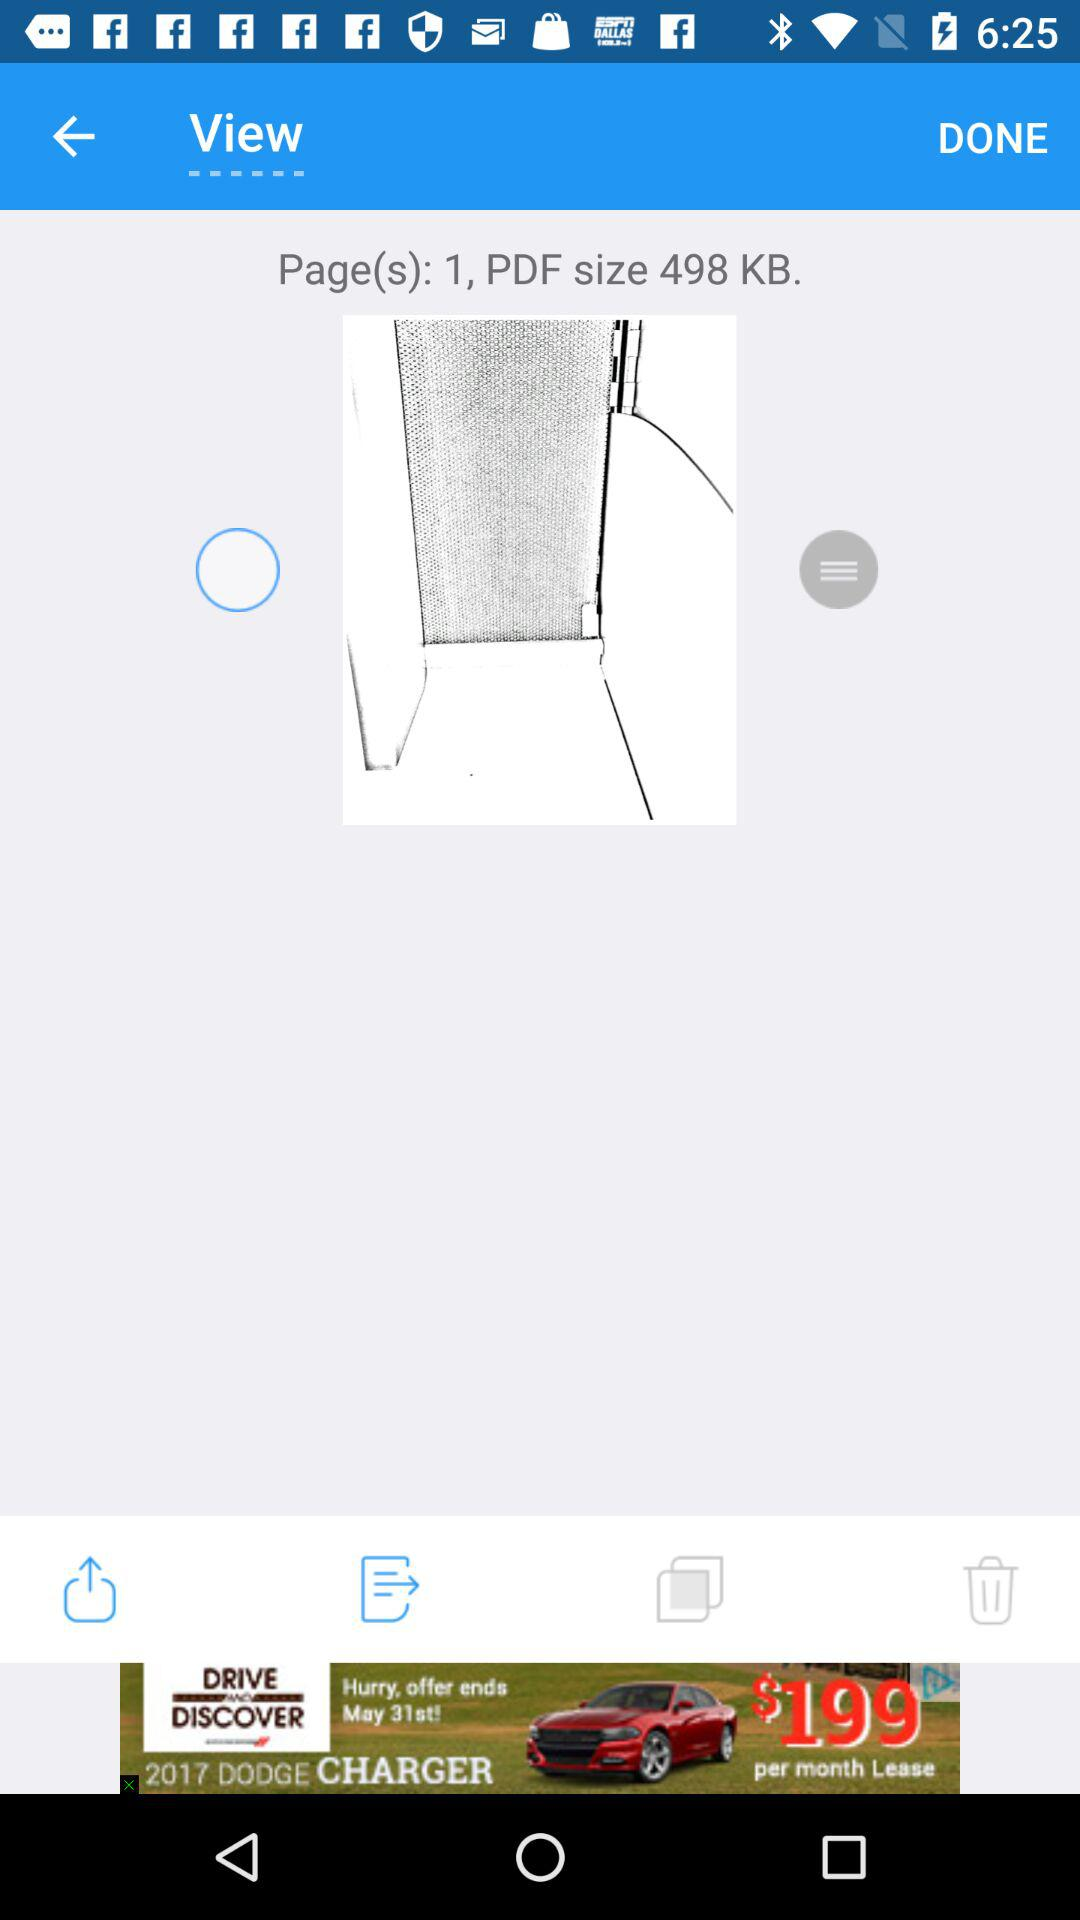How many KB is the PDF file?
Answer the question using a single word or phrase. 498 